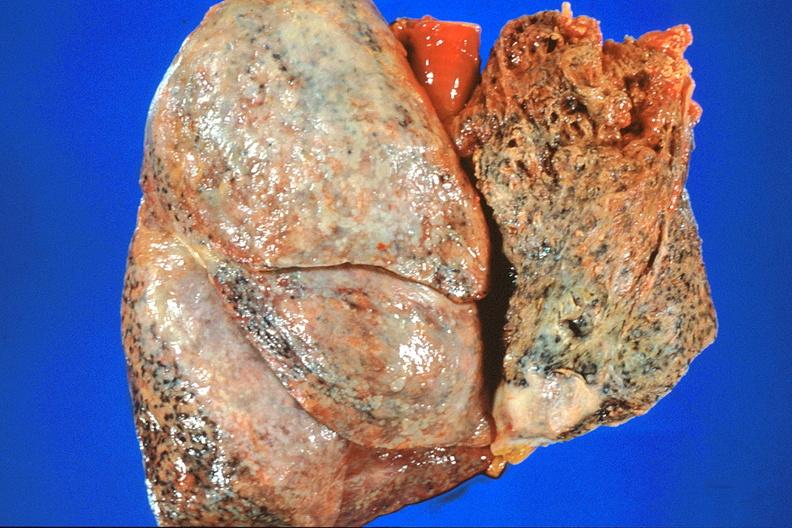s coronary artery present?
Answer the question using a single word or phrase. No 